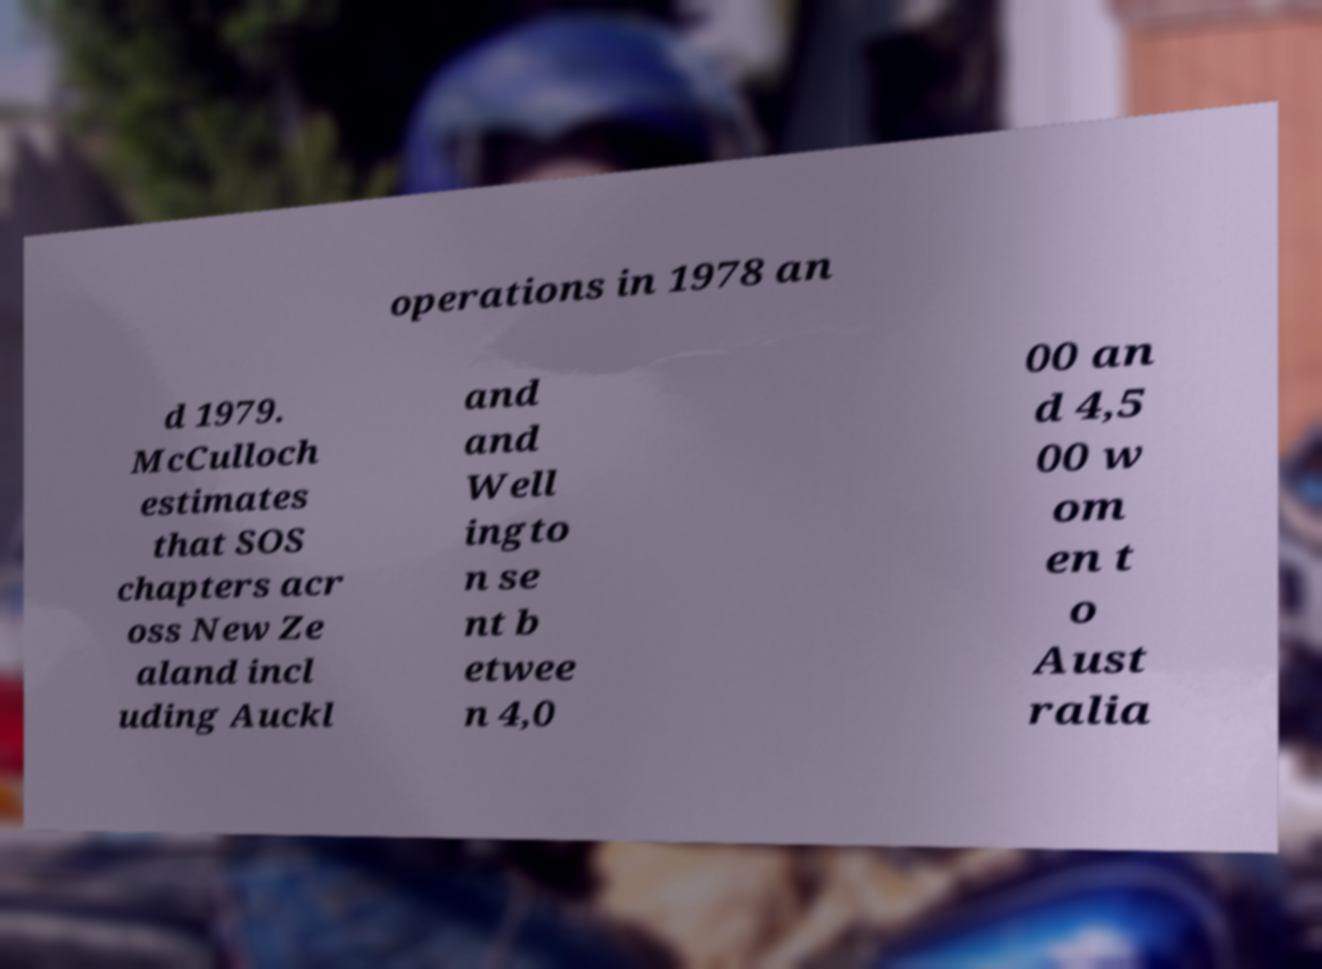There's text embedded in this image that I need extracted. Can you transcribe it verbatim? operations in 1978 an d 1979. McCulloch estimates that SOS chapters acr oss New Ze aland incl uding Auckl and and Well ingto n se nt b etwee n 4,0 00 an d 4,5 00 w om en t o Aust ralia 